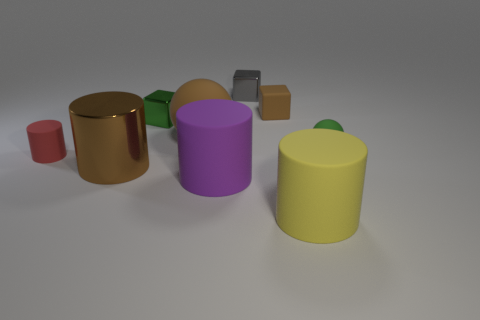There is a metal thing that is the same size as the gray cube; what is its color?
Offer a terse response. Green. Are there any tiny brown matte objects that have the same shape as the big purple thing?
Provide a short and direct response. No. Is the number of tiny matte blocks less than the number of cyan metallic balls?
Make the answer very short. No. There is a matte cylinder behind the large metallic object; what is its color?
Give a very brief answer. Red. There is a brown thing in front of the small object that is on the left side of the brown cylinder; what shape is it?
Your answer should be compact. Cylinder. Is the material of the yellow cylinder the same as the brown object in front of the small red rubber cylinder?
Your answer should be very brief. No. What shape is the rubber object that is the same color as the small matte cube?
Your response must be concise. Sphere. How many red matte cylinders have the same size as the purple matte cylinder?
Your answer should be very brief. 0. Are there fewer brown cylinders that are behind the green rubber sphere than large gray rubber spheres?
Ensure brevity in your answer.  No. How many tiny gray shiny cubes are left of the tiny gray thing?
Your response must be concise. 0. 